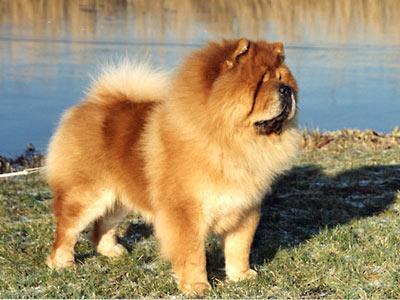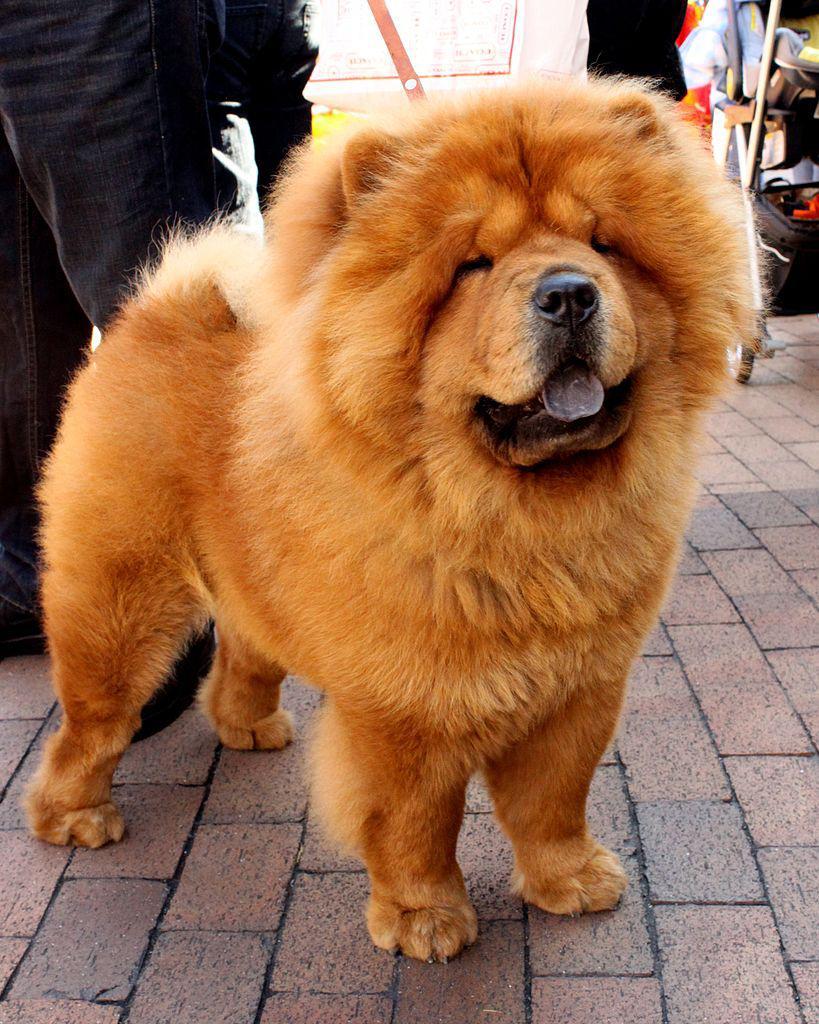The first image is the image on the left, the second image is the image on the right. Considering the images on both sides, is "The left image is a of a single dog standing on grass facing right." valid? Answer yes or no. Yes. The first image is the image on the left, the second image is the image on the right. For the images displayed, is the sentence "An image shows only one dog, which is standing on grass and has a closed mouth." factually correct? Answer yes or no. Yes. 